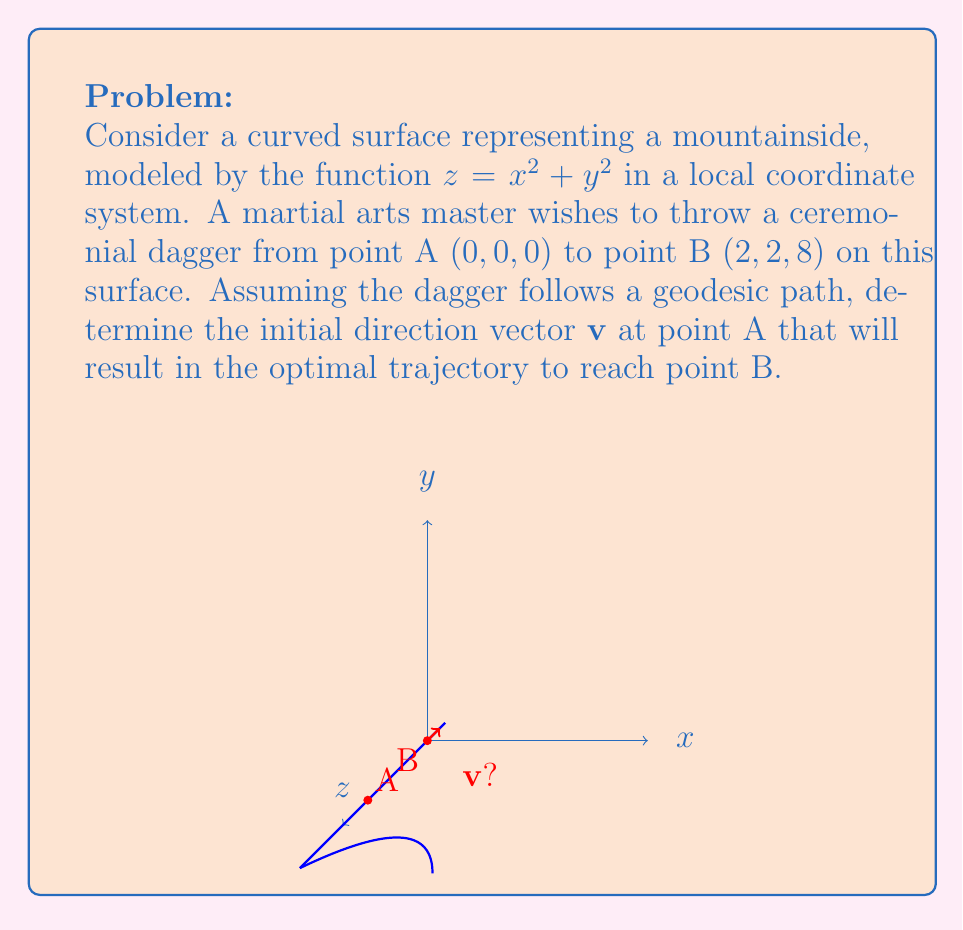Teach me how to tackle this problem. To solve this problem, we need to follow these steps:

1) The geodesic equation on a surface $z = f(x,y)$ is given by:

   $$\frac{d^2x}{ds^2} + \Gamma^x_{xx}\left(\frac{dx}{ds}\right)^2 + 2\Gamma^x_{xy}\frac{dx}{ds}\frac{dy}{ds} + \Gamma^x_{yy}\left(\frac{dy}{ds}\right)^2 = 0$$
   $$\frac{d^2y}{ds^2} + \Gamma^y_{xx}\left(\frac{dx}{ds}\right)^2 + 2\Gamma^y_{xy}\frac{dx}{ds}\frac{dy}{ds} + \Gamma^y_{yy}\left(\frac{dy}{ds}\right)^2 = 0$$

   where $\Gamma^i_{jk}$ are the Christoffel symbols.

2) For our surface $z = x^2 + y^2$, the Christoffel symbols are:

   $$\Gamma^x_{xx} = \frac{2x}{1+4x^2+4y^2}, \Gamma^x_{xy} = \Gamma^x_{yx} = \frac{2y}{1+4x^2+4y^2}, \Gamma^x_{yy} = \frac{-2x}{1+4x^2+4y^2}$$
   $$\Gamma^y_{xx} = \frac{-2y}{1+4x^2+4y^2}, \Gamma^y_{xy} = \Gamma^y_{yx} = \frac{2x}{1+4x^2+4y^2}, \Gamma^y_{yy} = \frac{2y}{1+4x^2+4y^2}$$

3) At the initial point A (0,0,0), all Christoffel symbols are zero. This simplifies our geodesic equations to:

   $$\frac{d^2x}{ds^2} = 0, \frac{d^2y}{ds^2} = 0$$

4) The solutions to these equations are linear:

   $$x(s) = as, y(s) = bs$$

   where $a$ and $b$ are constants determining the initial direction.

5) We need to find $a$ and $b$ such that the curve reaches point B (2,2,8). The parameter $s$ at point B will be the arc length of the geodesic.

6) The arc length $s$ can be calculated using:

   $$s = \int_0^s \sqrt{1 + \left(\frac{dx}{dt}\right)^2 + \left(\frac{dy}{dt}\right)^2 + \left(\frac{dz}{dt}\right)^2} dt$$

   $$= \int_0^s \sqrt{1 + a^2 + b^2 + 4(at)^2 + 4(bt)^2} dt$$

7) This integral is complex, but we can use the fact that at point B, $x = 2$ and $y = 2$. So:

   $$2 = as, 2 = bs$$

   This means $a = b = \frac{2}{s}$.

8) The initial direction vector $\mathbf{v}$ is proportional to $(a, b, 2ab)$ = $(1, 1, 2)$.

Therefore, the optimal initial direction vector is $\mathbf{v} = (1, 1, 2)$.
Answer: $\mathbf{v} = (1, 1, 2)$ 